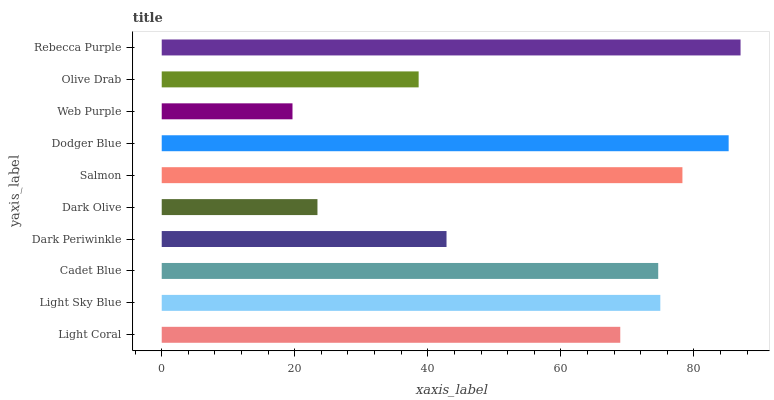Is Web Purple the minimum?
Answer yes or no. Yes. Is Rebecca Purple the maximum?
Answer yes or no. Yes. Is Light Sky Blue the minimum?
Answer yes or no. No. Is Light Sky Blue the maximum?
Answer yes or no. No. Is Light Sky Blue greater than Light Coral?
Answer yes or no. Yes. Is Light Coral less than Light Sky Blue?
Answer yes or no. Yes. Is Light Coral greater than Light Sky Blue?
Answer yes or no. No. Is Light Sky Blue less than Light Coral?
Answer yes or no. No. Is Cadet Blue the high median?
Answer yes or no. Yes. Is Light Coral the low median?
Answer yes or no. Yes. Is Rebecca Purple the high median?
Answer yes or no. No. Is Cadet Blue the low median?
Answer yes or no. No. 